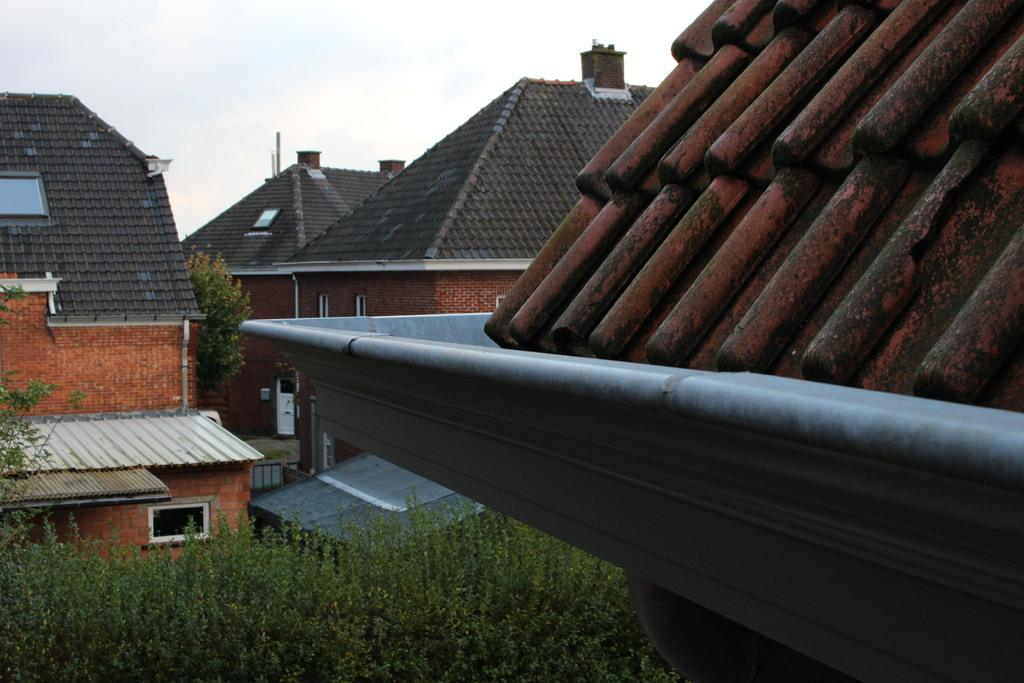What type of structures are present in the image? There is a group of buildings in the image. What architectural feature can be seen on the buildings? Roof tiles are visible in the image. What type of vegetation is present in the image? There are plants in the image. What is visible in the background of the image? The sky is visible in the background of the image. What type of bread is being served for dinner in the image? There is no dinner or bread present in the image; it features a group of buildings with roof tiles and plants. What is the source of heat for the buildings in the image? The image does not provide information about the source of heat for the buildings. 